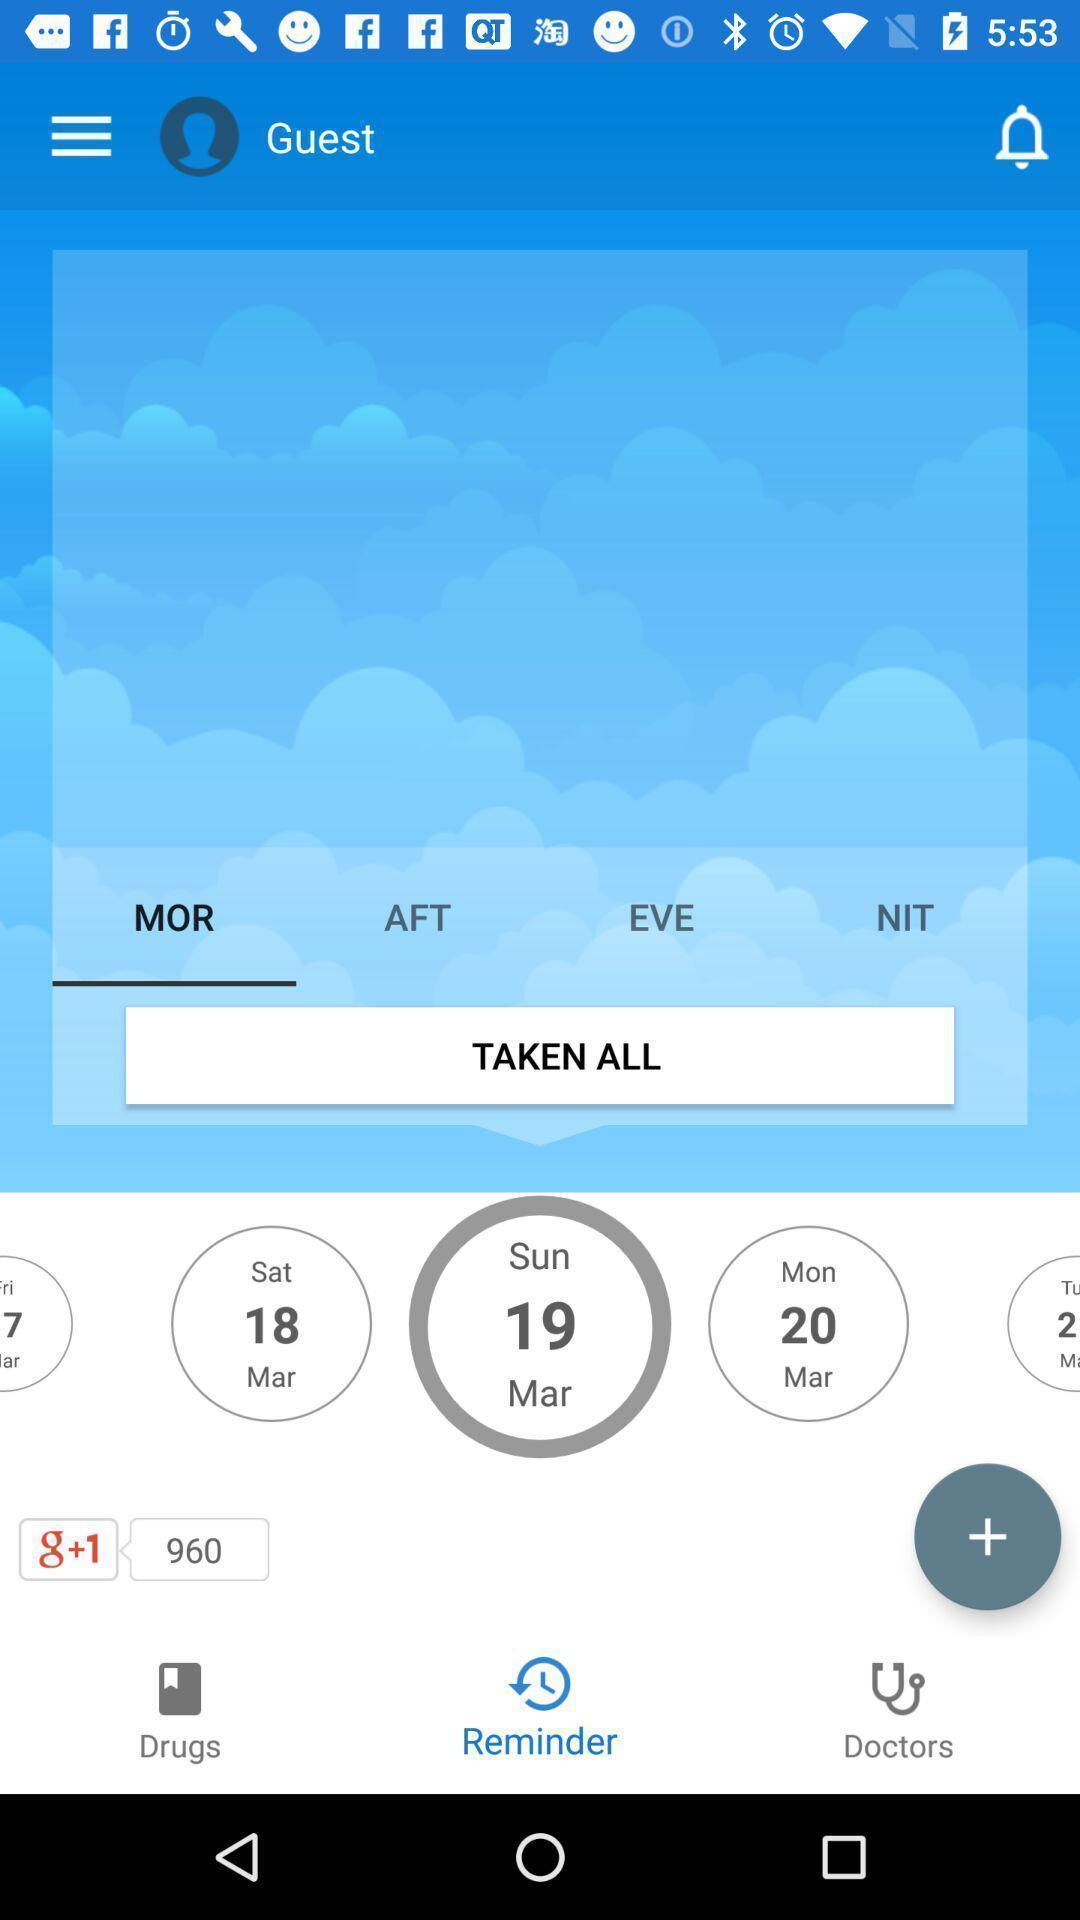Explain what's happening in this screen capture. Window displaying a medical app. 